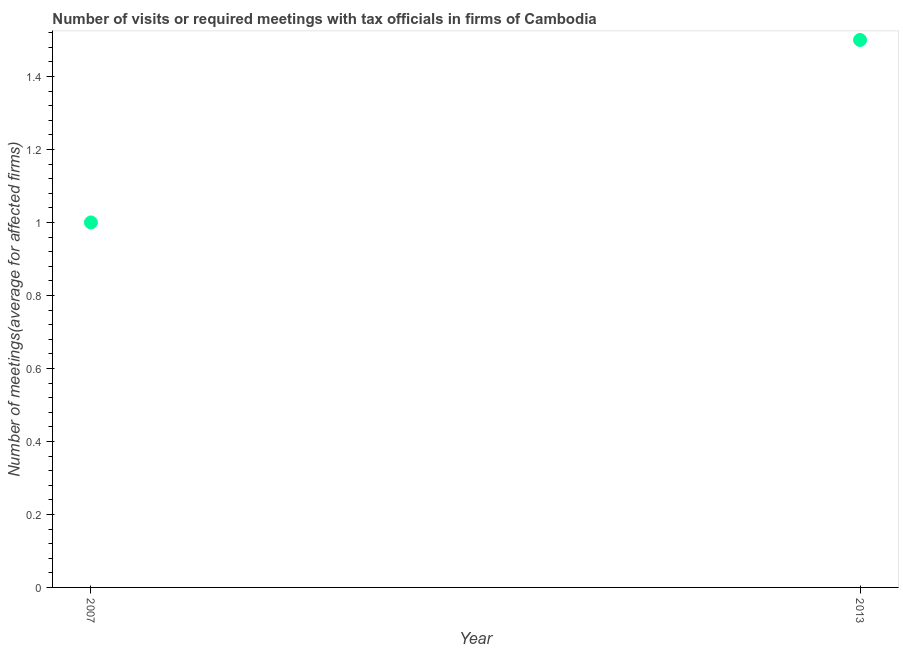Across all years, what is the minimum number of required meetings with tax officials?
Offer a terse response. 1. What is the median number of required meetings with tax officials?
Make the answer very short. 1.25. In how many years, is the number of required meetings with tax officials greater than 0.92 ?
Offer a very short reply. 2. What is the ratio of the number of required meetings with tax officials in 2007 to that in 2013?
Offer a very short reply. 0.67. Is the number of required meetings with tax officials in 2007 less than that in 2013?
Keep it short and to the point. Yes. In how many years, is the number of required meetings with tax officials greater than the average number of required meetings with tax officials taken over all years?
Give a very brief answer. 1. How many dotlines are there?
Provide a short and direct response. 1. Does the graph contain any zero values?
Offer a terse response. No. What is the title of the graph?
Your answer should be very brief. Number of visits or required meetings with tax officials in firms of Cambodia. What is the label or title of the Y-axis?
Your response must be concise. Number of meetings(average for affected firms). What is the Number of meetings(average for affected firms) in 2013?
Provide a short and direct response. 1.5. What is the ratio of the Number of meetings(average for affected firms) in 2007 to that in 2013?
Your response must be concise. 0.67. 